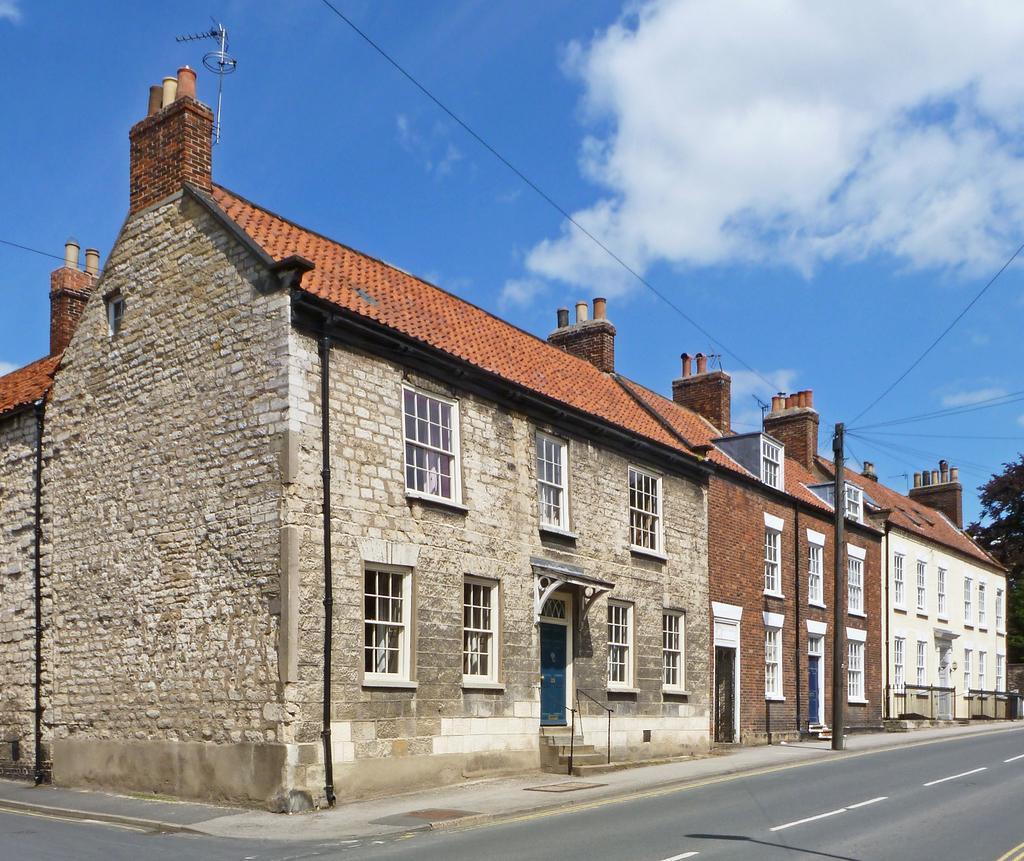In one or two sentences, can you explain what this image depicts? In this image I can see few buildings, windows, doors, few stairs, pole, wires, road and trees. The sky is in blue and white color. 